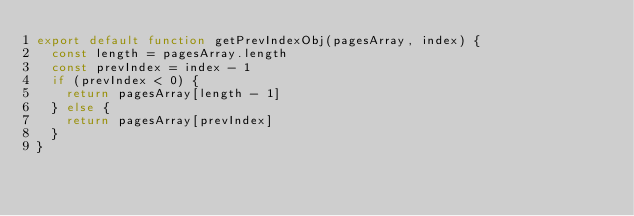<code> <loc_0><loc_0><loc_500><loc_500><_JavaScript_>export default function getPrevIndexObj(pagesArray, index) {
  const length = pagesArray.length
  const prevIndex = index - 1
  if (prevIndex < 0) {
    return pagesArray[length - 1]
  } else {
    return pagesArray[prevIndex]
  }
}
</code> 